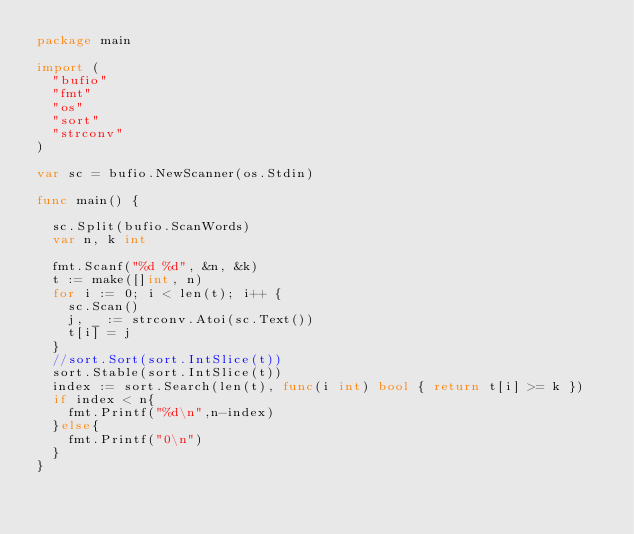Convert code to text. <code><loc_0><loc_0><loc_500><loc_500><_Go_>package main

import (
	"bufio"
	"fmt"
	"os"
	"sort"
	"strconv"
)

var sc = bufio.NewScanner(os.Stdin)

func main() {

	sc.Split(bufio.ScanWords)
	var n, k int

	fmt.Scanf("%d %d", &n, &k)
	t := make([]int, n)
	for i := 0; i < len(t); i++ {
		sc.Scan()
		j, _ := strconv.Atoi(sc.Text())
		t[i] = j
	}
	//sort.Sort(sort.IntSlice(t))
	sort.Stable(sort.IntSlice(t))
	index := sort.Search(len(t), func(i int) bool { return t[i] >= k })
	if index < n{
		fmt.Printf("%d\n",n-index)
	}else{
		fmt.Printf("0\n")
	}
}
</code> 